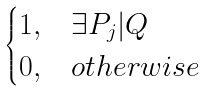Convert formula to latex. <formula><loc_0><loc_0><loc_500><loc_500>\begin{cases} 1 , & \exists P _ { j } | Q \\ 0 , & o t h e r w i s e \end{cases}</formula> 